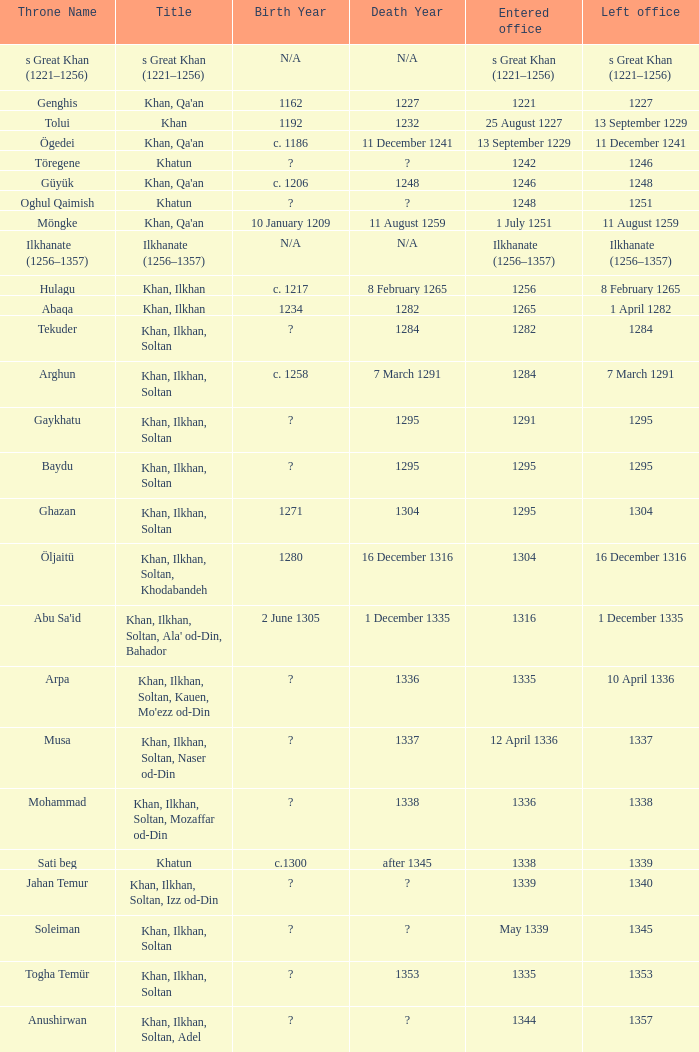Parse the table in full. {'header': ['Throne Name', 'Title', 'Birth Year', 'Death Year', 'Entered office', 'Left office'], 'rows': [['s Great Khan (1221–1256)', 's Great Khan (1221–1256)', 'N/A', 'N/A', 's Great Khan (1221–1256)', 's Great Khan (1221–1256)'], ['Genghis', "Khan, Qa'an", '1162', '1227', '1221', '1227'], ['Tolui', 'Khan', '1192', '1232', '25 August 1227', '13 September 1229'], ['Ögedei', "Khan, Qa'an", 'c. 1186', '11 December 1241', '13 September 1229', '11 December 1241'], ['Töregene', 'Khatun', '?', '?', '1242', '1246'], ['Güyük', "Khan, Qa'an", 'c. 1206', '1248', '1246', '1248'], ['Oghul Qaimish', 'Khatun', '?', '?', '1248', '1251'], ['Möngke', "Khan, Qa'an", '10 January 1209', '11 August 1259', '1 July 1251', '11 August 1259'], ['Ilkhanate (1256–1357)', 'Ilkhanate (1256–1357)', 'N/A', 'N/A', 'Ilkhanate (1256–1357)', 'Ilkhanate (1256–1357)'], ['Hulagu', 'Khan, Ilkhan', 'c. 1217', '8 February 1265', '1256', '8 February 1265'], ['Abaqa', 'Khan, Ilkhan', '1234', '1282', '1265', '1 April 1282'], ['Tekuder', 'Khan, Ilkhan, Soltan', '?', '1284', '1282', '1284'], ['Arghun', 'Khan, Ilkhan, Soltan', 'c. 1258', '7 March 1291', '1284', '7 March 1291'], ['Gaykhatu', 'Khan, Ilkhan, Soltan', '?', '1295', '1291', '1295'], ['Baydu', 'Khan, Ilkhan, Soltan', '?', '1295', '1295', '1295'], ['Ghazan', 'Khan, Ilkhan, Soltan', '1271', '1304', '1295', '1304'], ['Öljaitü', 'Khan, Ilkhan, Soltan, Khodabandeh', '1280', '16 December 1316', '1304', '16 December 1316'], ["Abu Sa'id", "Khan, Ilkhan, Soltan, Ala' od-Din, Bahador", '2 June 1305', '1 December 1335', '1316', '1 December 1335'], ['Arpa', "Khan, Ilkhan, Soltan, Kauen, Mo'ezz od-Din", '?', '1336', '1335', '10 April 1336'], ['Musa', 'Khan, Ilkhan, Soltan, Naser od-Din', '?', '1337', '12 April 1336', '1337'], ['Mohammad', 'Khan, Ilkhan, Soltan, Mozaffar od-Din', '?', '1338', '1336', '1338'], ['Sati beg', 'Khatun', 'c.1300', 'after 1345', '1338', '1339'], ['Jahan Temur', 'Khan, Ilkhan, Soltan, Izz od-Din', '?', '?', '1339', '1340'], ['Soleiman', 'Khan, Ilkhan, Soltan', '?', '?', 'May 1339', '1345'], ['Togha Temür', 'Khan, Ilkhan, Soltan', '?', '1353', '1335', '1353'], ['Anushirwan', 'Khan, Ilkhan, Soltan, Adel', '?', '?', '1344', '1357']]} What is the entered office that has 1337 as the left office? 12 April 1336. 